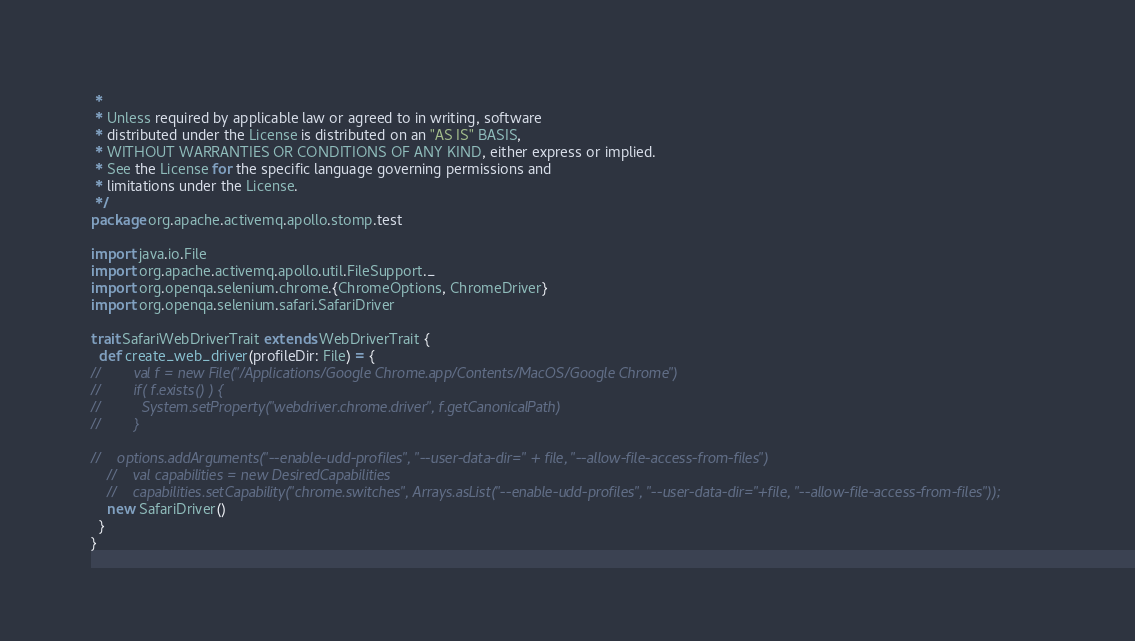Convert code to text. <code><loc_0><loc_0><loc_500><loc_500><_Scala_> *
 * Unless required by applicable law or agreed to in writing, software
 * distributed under the License is distributed on an "AS IS" BASIS,
 * WITHOUT WARRANTIES OR CONDITIONS OF ANY KIND, either express or implied.
 * See the License for the specific language governing permissions and
 * limitations under the License.
 */
package org.apache.activemq.apollo.stomp.test

import java.io.File
import org.apache.activemq.apollo.util.FileSupport._
import org.openqa.selenium.chrome.{ChromeOptions, ChromeDriver}
import org.openqa.selenium.safari.SafariDriver

trait SafariWebDriverTrait extends WebDriverTrait {
  def create_web_driver(profileDir: File) = {
//        val f = new File("/Applications/Google Chrome.app/Contents/MacOS/Google Chrome")
//        if( f.exists() ) {
//          System.setProperty("webdriver.chrome.driver", f.getCanonicalPath)
//        }

//    options.addArguments("--enable-udd-profiles", "--user-data-dir=" + file, "--allow-file-access-from-files")
    //    val capabilities = new DesiredCapabilities
    //    capabilities.setCapability("chrome.switches", Arrays.asList("--enable-udd-profiles", "--user-data-dir="+file, "--allow-file-access-from-files"));
    new SafariDriver()
  }
}</code> 